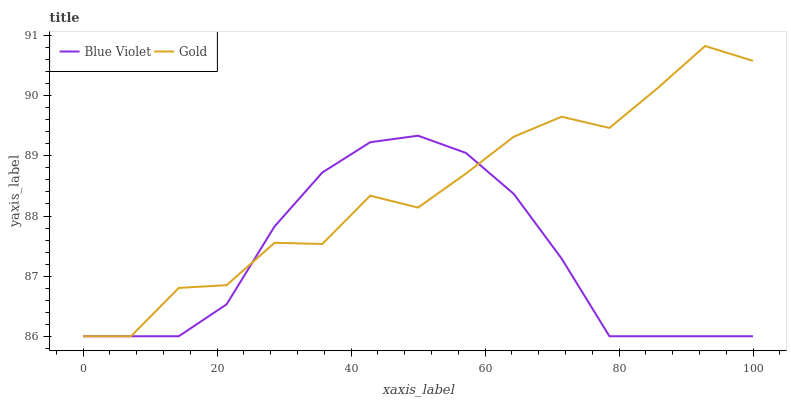Does Blue Violet have the minimum area under the curve?
Answer yes or no. Yes. Does Gold have the maximum area under the curve?
Answer yes or no. Yes. Does Blue Violet have the maximum area under the curve?
Answer yes or no. No. Is Blue Violet the smoothest?
Answer yes or no. Yes. Is Gold the roughest?
Answer yes or no. Yes. Is Blue Violet the roughest?
Answer yes or no. No. Does Blue Violet have the highest value?
Answer yes or no. No. 